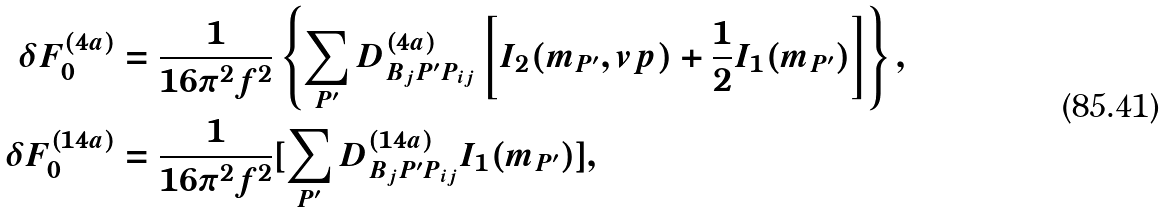Convert formula to latex. <formula><loc_0><loc_0><loc_500><loc_500>\delta F _ { 0 } ^ { ( 4 a ) } & = \frac { 1 } { 1 6 \pi ^ { 2 } f ^ { 2 } } \left \{ \sum _ { P ^ { \prime } } D _ { B _ { j } P ^ { \prime } P _ { i j } } ^ { ( 4 a ) } \left [ I _ { 2 } ( m _ { P ^ { \prime } } , v p ) + \frac { 1 } { 2 } I _ { 1 } ( m _ { P ^ { \prime } } ) \right ] \right \} , \\ \delta F _ { 0 } ^ { ( 1 4 a ) } & = \frac { 1 } { 1 6 \pi ^ { 2 } f ^ { 2 } } [ \sum _ { P ^ { \prime } } D _ { B _ { j } P ^ { \prime } P _ { i j } } ^ { ( 1 4 a ) } I _ { 1 } ( m _ { P ^ { \prime } } ) ] ,</formula> 